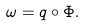Convert formula to latex. <formula><loc_0><loc_0><loc_500><loc_500>\omega = q \circ \Phi .</formula> 